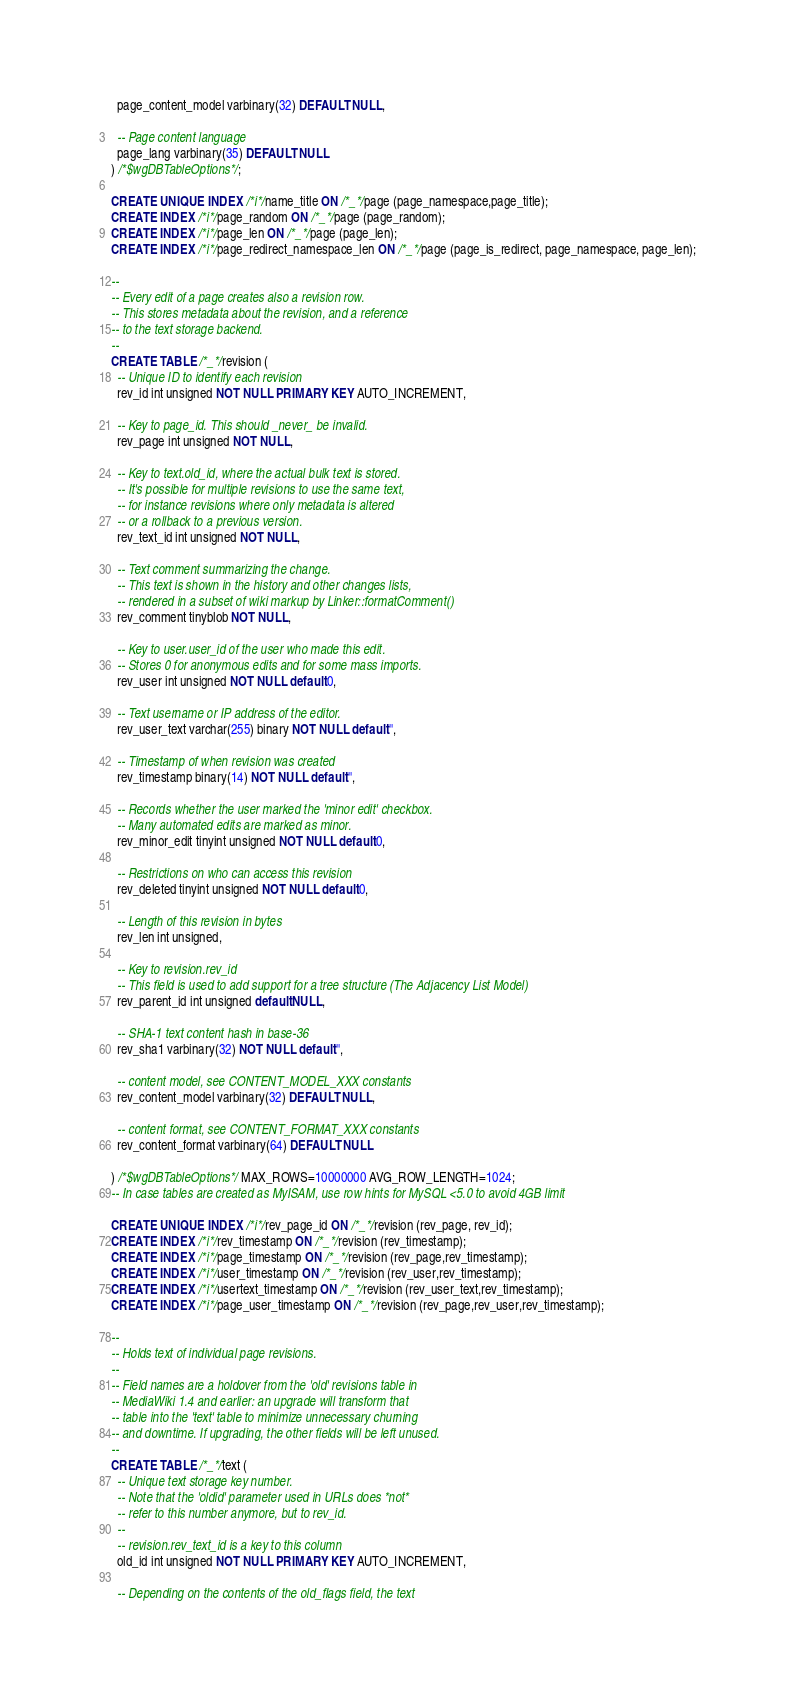Convert code to text. <code><loc_0><loc_0><loc_500><loc_500><_SQL_>  page_content_model varbinary(32) DEFAULT NULL,

  -- Page content language
  page_lang varbinary(35) DEFAULT NULL
) /*$wgDBTableOptions*/;

CREATE UNIQUE INDEX /*i*/name_title ON /*_*/page (page_namespace,page_title);
CREATE INDEX /*i*/page_random ON /*_*/page (page_random);
CREATE INDEX /*i*/page_len ON /*_*/page (page_len);
CREATE INDEX /*i*/page_redirect_namespace_len ON /*_*/page (page_is_redirect, page_namespace, page_len);

--
-- Every edit of a page creates also a revision row.
-- This stores metadata about the revision, and a reference
-- to the text storage backend.
--
CREATE TABLE /*_*/revision (
  -- Unique ID to identify each revision
  rev_id int unsigned NOT NULL PRIMARY KEY AUTO_INCREMENT,

  -- Key to page_id. This should _never_ be invalid.
  rev_page int unsigned NOT NULL,

  -- Key to text.old_id, where the actual bulk text is stored.
  -- It's possible for multiple revisions to use the same text,
  -- for instance revisions where only metadata is altered
  -- or a rollback to a previous version.
  rev_text_id int unsigned NOT NULL,

  -- Text comment summarizing the change.
  -- This text is shown in the history and other changes lists,
  -- rendered in a subset of wiki markup by Linker::formatComment()
  rev_comment tinyblob NOT NULL,

  -- Key to user.user_id of the user who made this edit.
  -- Stores 0 for anonymous edits and for some mass imports.
  rev_user int unsigned NOT NULL default 0,

  -- Text username or IP address of the editor.
  rev_user_text varchar(255) binary NOT NULL default '',

  -- Timestamp of when revision was created
  rev_timestamp binary(14) NOT NULL default '',

  -- Records whether the user marked the 'minor edit' checkbox.
  -- Many automated edits are marked as minor.
  rev_minor_edit tinyint unsigned NOT NULL default 0,

  -- Restrictions on who can access this revision
  rev_deleted tinyint unsigned NOT NULL default 0,

  -- Length of this revision in bytes
  rev_len int unsigned,

  -- Key to revision.rev_id
  -- This field is used to add support for a tree structure (The Adjacency List Model)
  rev_parent_id int unsigned default NULL,

  -- SHA-1 text content hash in base-36
  rev_sha1 varbinary(32) NOT NULL default '',

  -- content model, see CONTENT_MODEL_XXX constants
  rev_content_model varbinary(32) DEFAULT NULL,

  -- content format, see CONTENT_FORMAT_XXX constants
  rev_content_format varbinary(64) DEFAULT NULL

) /*$wgDBTableOptions*/ MAX_ROWS=10000000 AVG_ROW_LENGTH=1024;
-- In case tables are created as MyISAM, use row hints for MySQL <5.0 to avoid 4GB limit

CREATE UNIQUE INDEX /*i*/rev_page_id ON /*_*/revision (rev_page, rev_id);
CREATE INDEX /*i*/rev_timestamp ON /*_*/revision (rev_timestamp);
CREATE INDEX /*i*/page_timestamp ON /*_*/revision (rev_page,rev_timestamp);
CREATE INDEX /*i*/user_timestamp ON /*_*/revision (rev_user,rev_timestamp);
CREATE INDEX /*i*/usertext_timestamp ON /*_*/revision (rev_user_text,rev_timestamp);
CREATE INDEX /*i*/page_user_timestamp ON /*_*/revision (rev_page,rev_user,rev_timestamp);

--
-- Holds text of individual page revisions.
--
-- Field names are a holdover from the 'old' revisions table in
-- MediaWiki 1.4 and earlier: an upgrade will transform that
-- table into the 'text' table to minimize unnecessary churning
-- and downtime. If upgrading, the other fields will be left unused.
--
CREATE TABLE /*_*/text (
  -- Unique text storage key number.
  -- Note that the 'oldid' parameter used in URLs does *not*
  -- refer to this number anymore, but to rev_id.
  --
  -- revision.rev_text_id is a key to this column
  old_id int unsigned NOT NULL PRIMARY KEY AUTO_INCREMENT,

  -- Depending on the contents of the old_flags field, the text</code> 